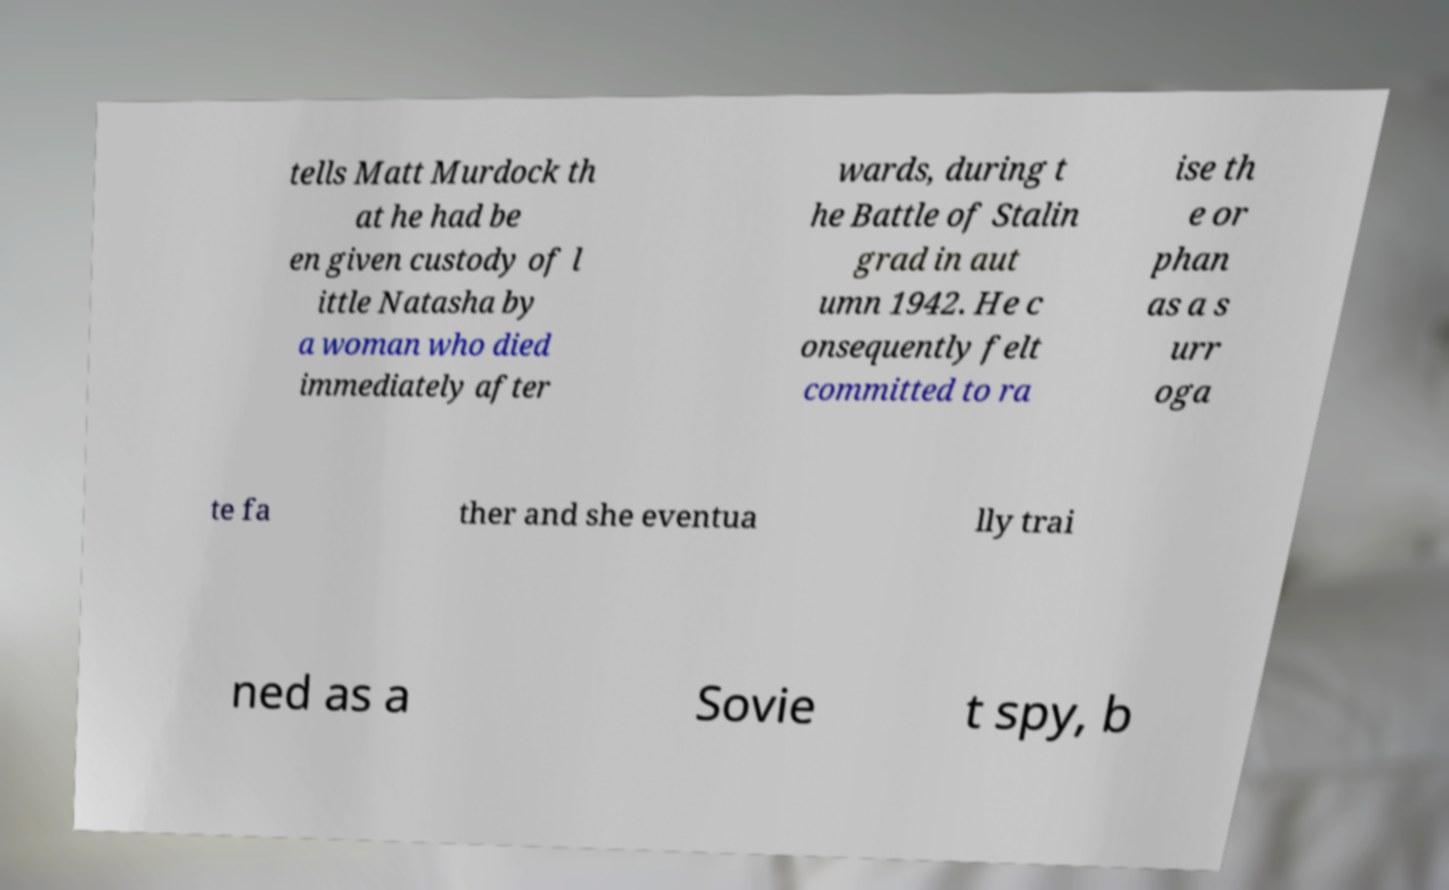What messages or text are displayed in this image? I need them in a readable, typed format. tells Matt Murdock th at he had be en given custody of l ittle Natasha by a woman who died immediately after wards, during t he Battle of Stalin grad in aut umn 1942. He c onsequently felt committed to ra ise th e or phan as a s urr oga te fa ther and she eventua lly trai ned as a Sovie t spy, b 